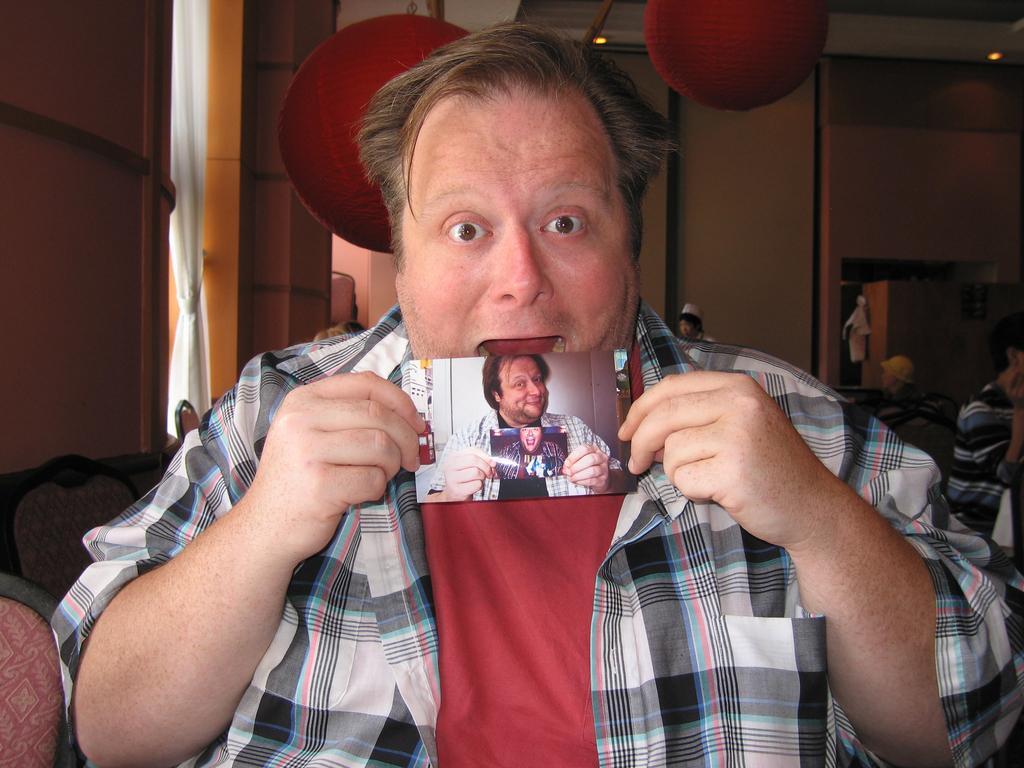Please provide a concise description of this image. In this image we can see a few people, chairs, photograph, on the left we can see window, curtain, we can see hanging lamp, ceiling with the lights. 